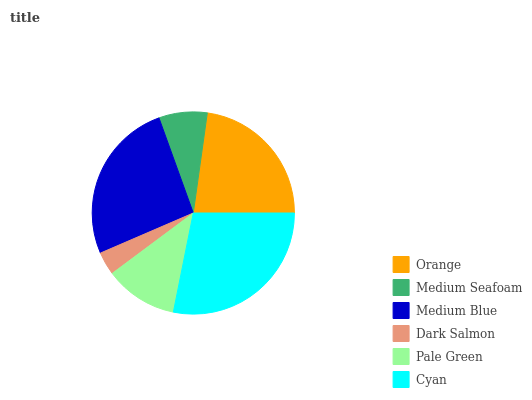Is Dark Salmon the minimum?
Answer yes or no. Yes. Is Cyan the maximum?
Answer yes or no. Yes. Is Medium Seafoam the minimum?
Answer yes or no. No. Is Medium Seafoam the maximum?
Answer yes or no. No. Is Orange greater than Medium Seafoam?
Answer yes or no. Yes. Is Medium Seafoam less than Orange?
Answer yes or no. Yes. Is Medium Seafoam greater than Orange?
Answer yes or no. No. Is Orange less than Medium Seafoam?
Answer yes or no. No. Is Orange the high median?
Answer yes or no. Yes. Is Pale Green the low median?
Answer yes or no. Yes. Is Medium Blue the high median?
Answer yes or no. No. Is Cyan the low median?
Answer yes or no. No. 